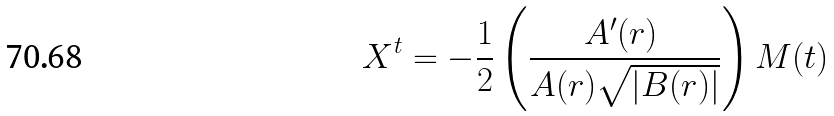Convert formula to latex. <formula><loc_0><loc_0><loc_500><loc_500>X ^ { t } = - \frac { 1 } { 2 } \left ( \frac { A ^ { \prime } ( r ) \ } { A ( r ) \sqrt { \left | B ( r ) \right | } } \right ) M ( t )</formula> 